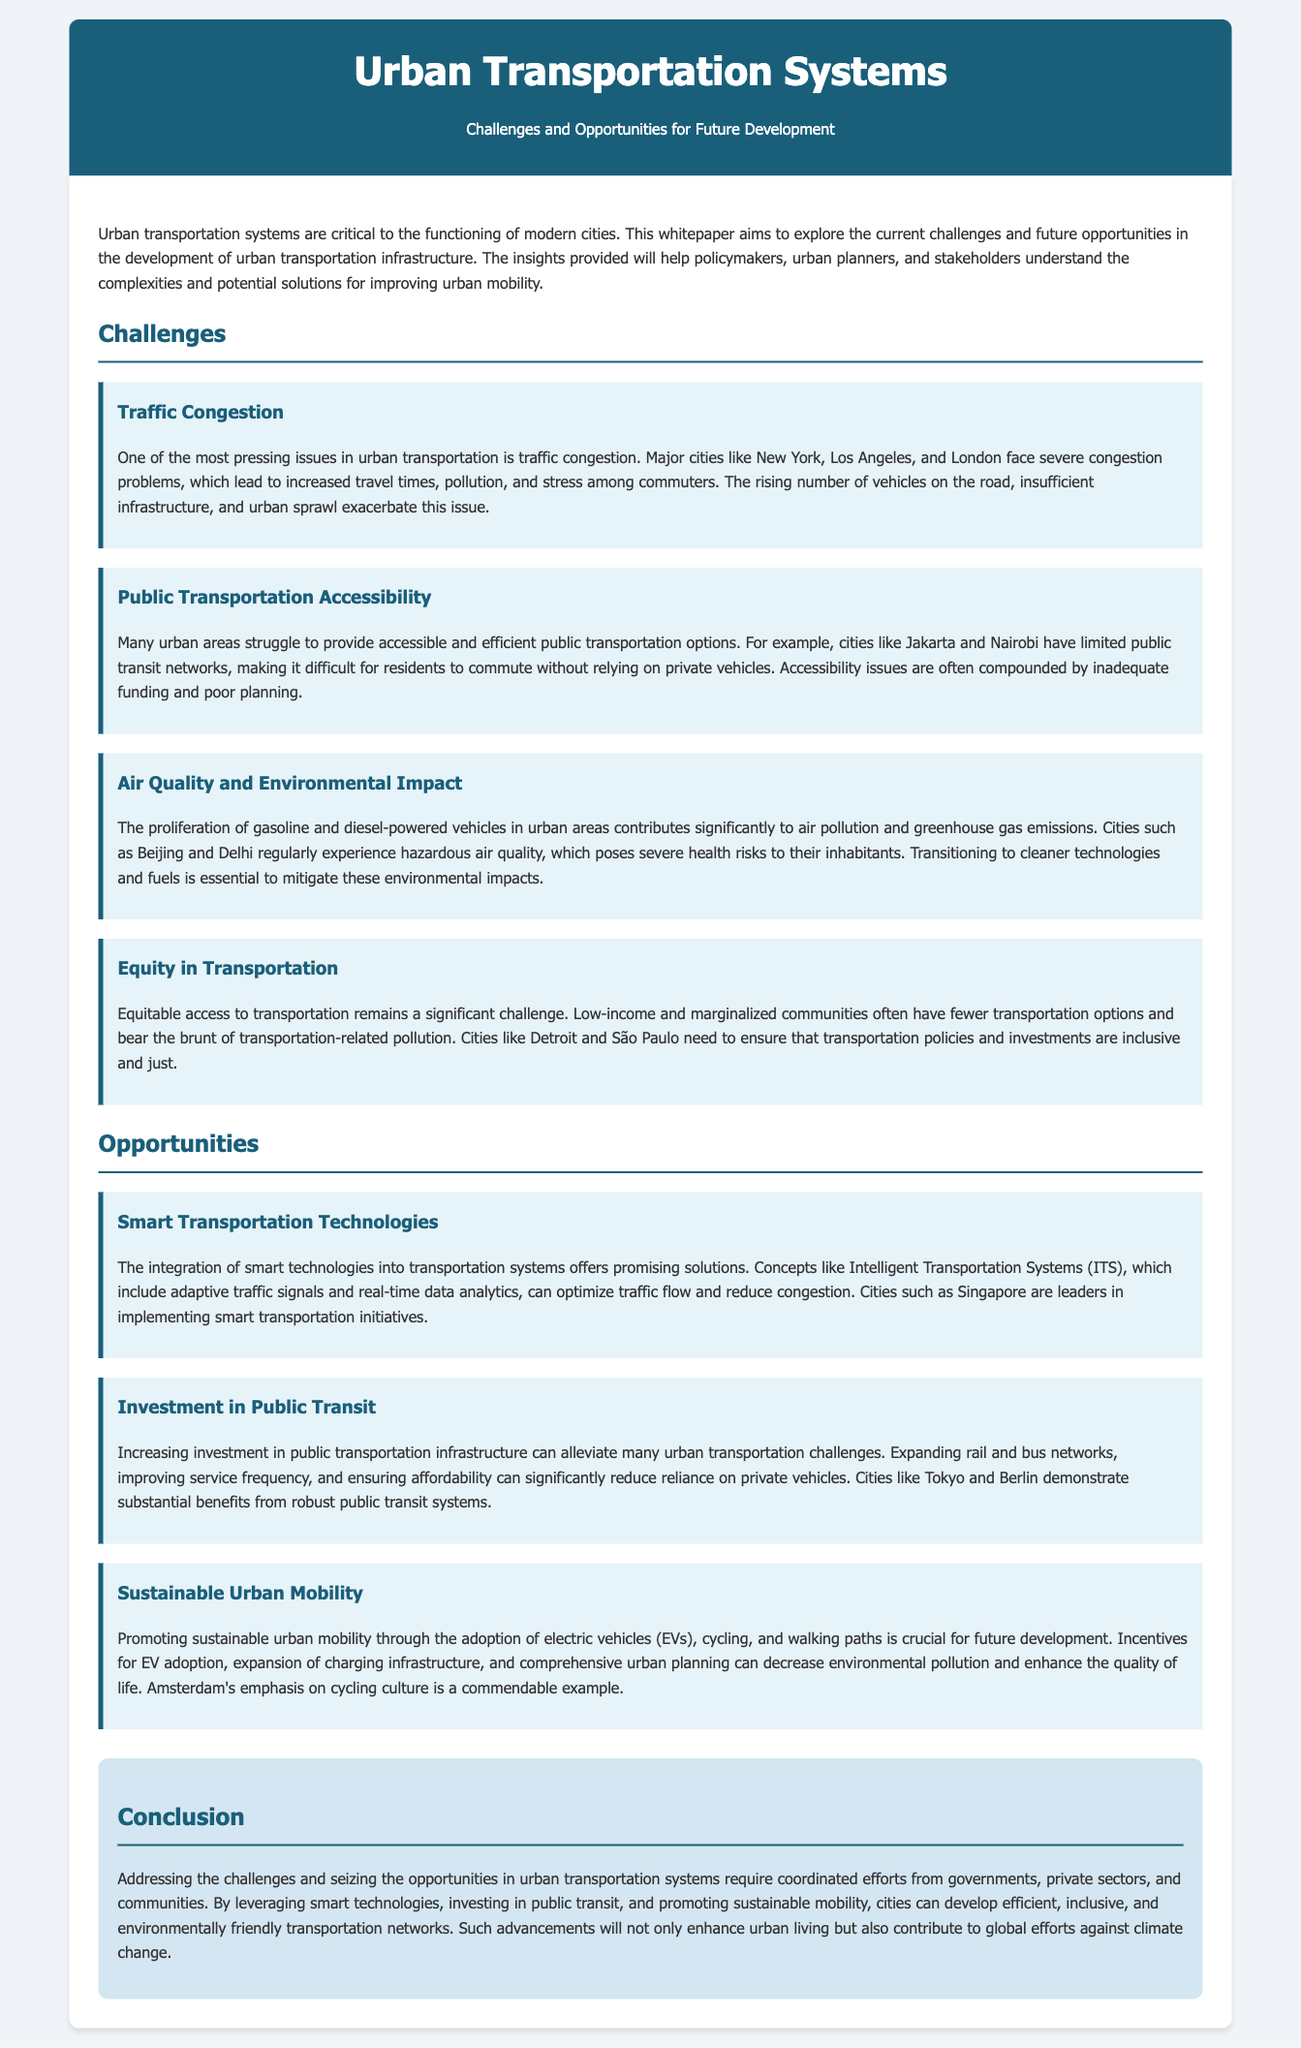What is the title of the whitepaper? The title appears prominently at the top of the document, indicating the focus of the content.
Answer: Urban Transportation Systems: Challenges and Opportunities What is one of the challenges mentioned related to urban transportation? The document explicitly lists several challenges, showcasing the critical issues facing urban transportation systems.
Answer: Traffic Congestion Which city is cited as having severe congestion problems? The document provides examples of cities suffering from traffic congestion to illustrate the point.
Answer: New York What technology is proposed as a solution for optimizing traffic flow? The text discusses the integration of specific technologies as part of smart transportation solutions.
Answer: Intelligent Transportation Systems (ITS) Which city is mentioned as a leader in implementing smart transportation initiatives? The document provides examples of cities that are successfully leveraging technology to improve transportation systems.
Answer: Singapore What is one opportunity for future urban transportation development? The document outlines opportunities that urban planners and policymakers can utilize to address transportation challenges.
Answer: Smart Transportation Technologies What is a key aspect of promoting sustainable urban mobility? The text highlights specific methods to enhance urban mobility, indicating how the future can be shaped.
Answer: Electric vehicles (EVs) What city is used as an example of a robust public transit system? The whitepaper references specific cities to demonstrate successful public transit strategies and their benefits.
Answer: Tokyo What is the conclusion about addressing urban transportation challenges? The conclusion summarizes the key takeaways regarding the necessity for collaborative efforts in addressing urban transport issues.
Answer: Coordinated efforts 